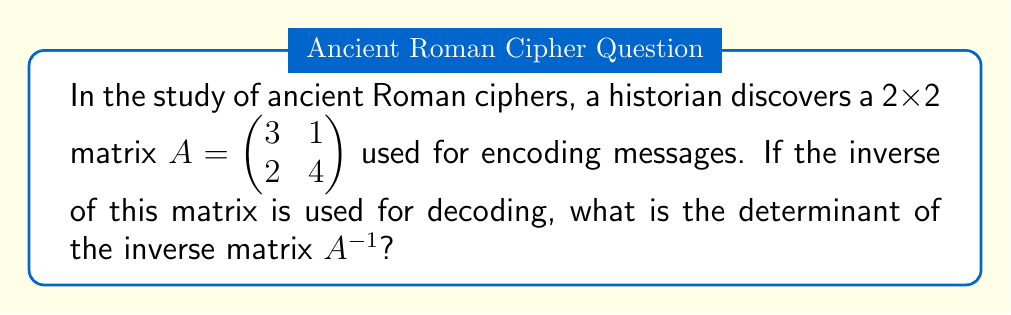Can you answer this question? To solve this problem, we'll follow these steps:

1) First, let's recall that for a 2x2 matrix $A = \begin{pmatrix} a & b \\ c & d \end{pmatrix}$, its determinant is calculated as:

   $\det(A) = ad - bc$

2) For our matrix $A = \begin{pmatrix} 3 & 1 \\ 2 & 4 \end{pmatrix}$, we calculate:

   $\det(A) = (3)(4) - (1)(2) = 12 - 2 = 10$

3) Now, we need to understand the relationship between a matrix and its inverse. For any invertible matrix $A$, we have:

   $\det(A^{-1}) = \frac{1}{\det(A)}$

   This is because $AA^{-1} = I$ (the identity matrix), and $\det(I) = 1$. So:

   $\det(A)\det(A^{-1}) = \det(AA^{-1}) = \det(I) = 1$

4) Therefore, for our matrix:

   $\det(A^{-1}) = \frac{1}{\det(A)} = \frac{1}{10}$

This result shows that the inverse matrix, which would be used for decoding, has a determinant that is the reciprocal of the original encoding matrix's determinant.
Answer: $\frac{1}{10}$ 